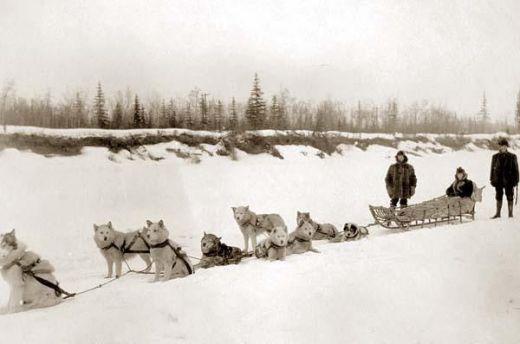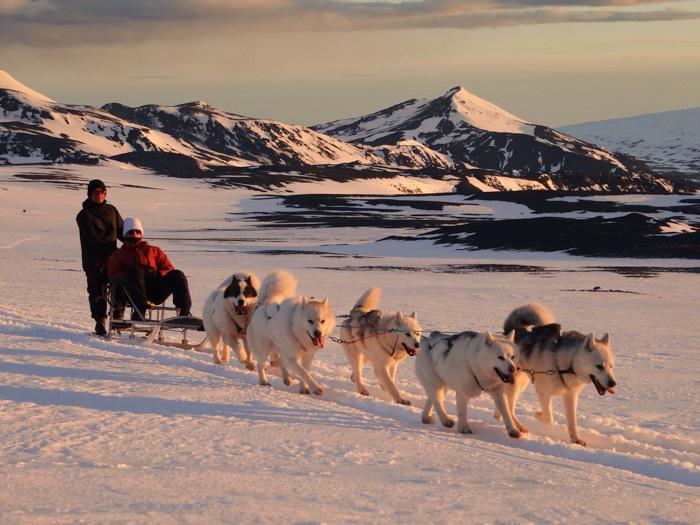The first image is the image on the left, the second image is the image on the right. Evaluate the accuracy of this statement regarding the images: "All the dogs are moving forward.". Is it true? Answer yes or no. No. The first image is the image on the left, the second image is the image on the right. Analyze the images presented: Is the assertion "in one of the images, a dogsled is headed towards the right." valid? Answer yes or no. Yes. 